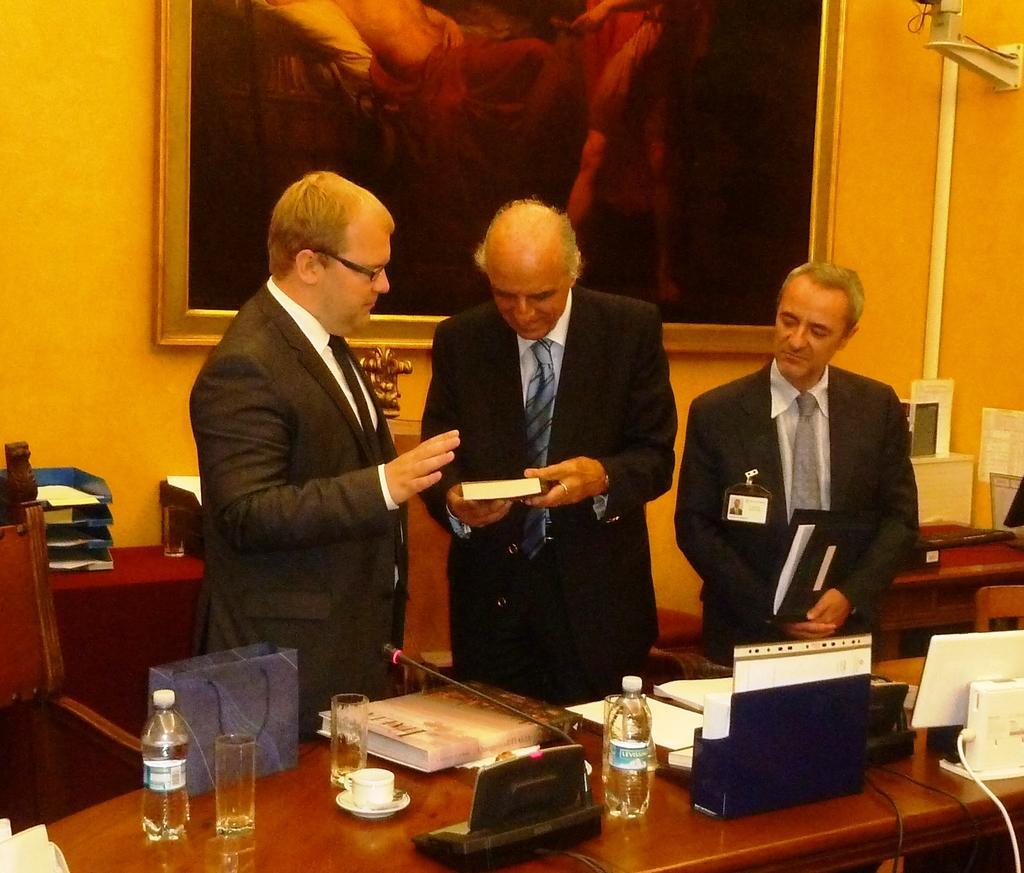Could you give a brief overview of what you see in this image? This is a picture taken in a room, there are three persons standing on the floor. The man in black blazer was holding a book and to the right side of the man there is other man holding a file. In front of the people there is a table on the table there are bottles, glasses, cup, saucer, book, papers and some items. Behind the people there is a wall with a frame, chair and files. 